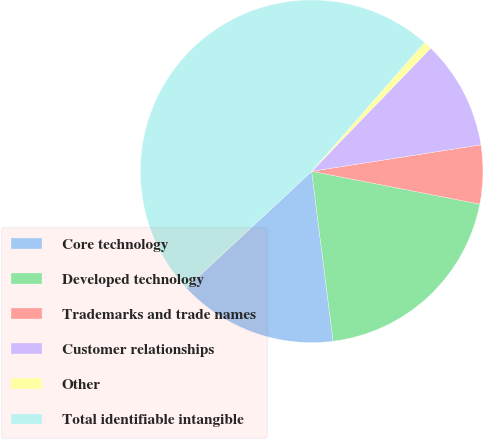<chart> <loc_0><loc_0><loc_500><loc_500><pie_chart><fcel>Core technology<fcel>Developed technology<fcel>Trademarks and trade names<fcel>Customer relationships<fcel>Other<fcel>Total identifiable intangible<nl><fcel>15.06%<fcel>19.94%<fcel>5.54%<fcel>10.3%<fcel>0.78%<fcel>48.39%<nl></chart> 